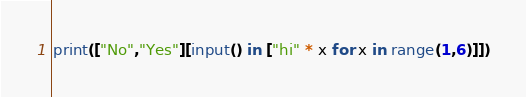<code> <loc_0><loc_0><loc_500><loc_500><_Python_>print(["No","Yes"][input() in ["hi" * x for x in range(1,6)]])</code> 